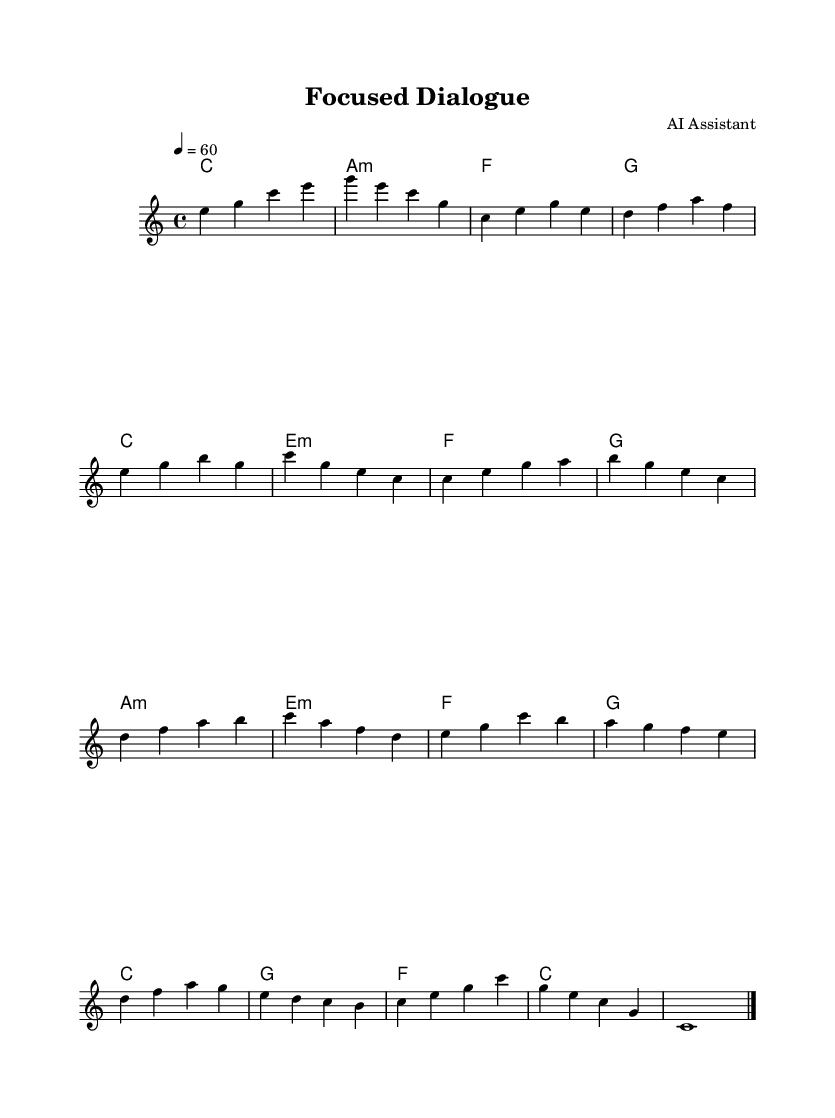What is the key signature of this music? The key signature is indicated at the beginning of the staff, showing no sharps or flats, which defines it as C major.
Answer: C major What is the time signature of this piece? The time signature is located next to the key signature, and it is written as 4/4, indicating four beats per measure.
Answer: 4/4 What is the tempo marking of the piece? The tempo marking is stated in the score, specifying a rate of 60 beats per minute. This gives a slow and steady pacing for the music.
Answer: 60 How many distinct musical sections are there in the main theme? By analyzing the melody part, there are two distinct phrases in the main theme, which can be counted separately before the variations begin.
Answer: 2 What type of mood does this music likely evoke? Considering "ambient soundscapes" typically aim for tranquility and focus, the harmonic structures and slow tempo suggest a calming mood.
Answer: Calming Which chord is played at the beginning of the score? The first chord indicated in the chord progression is C major, noted at the start of the harmonies section.
Answer: C What is the last note of the piece? The score ends with a note that is written as C, which is sustained as indicated by the whole note before the final bar line.
Answer: C 